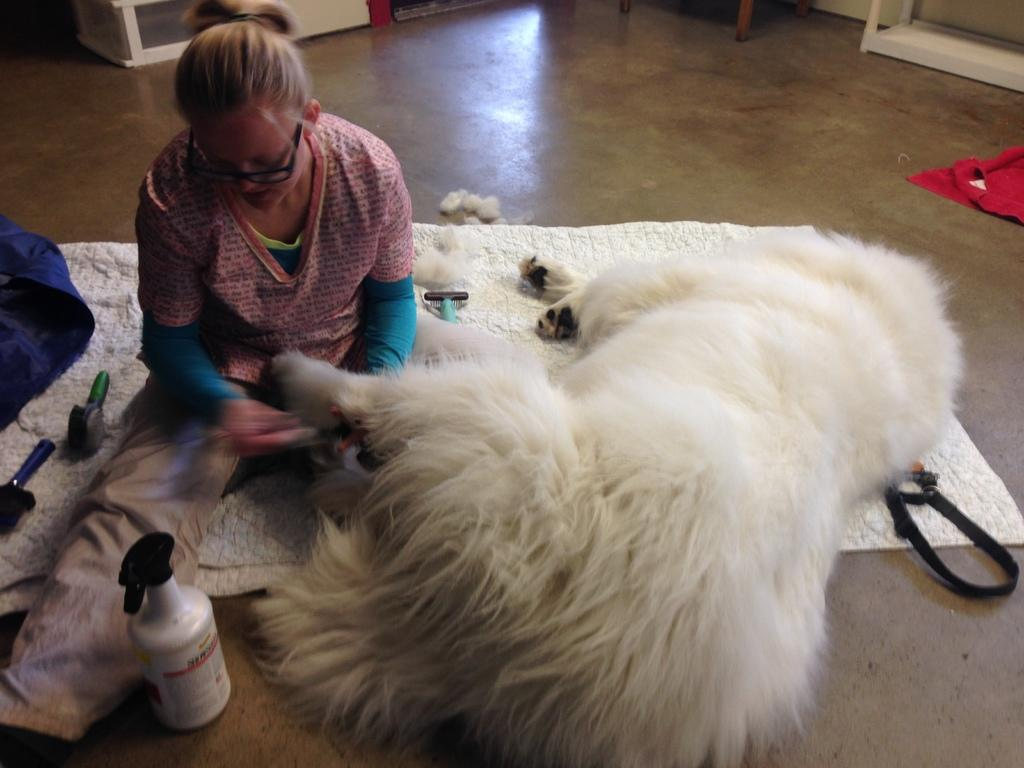What type of flooring is visible in the image? There is a floor in the image. What is on top of the floor? There is a white color carpet on the floor. What living creature can be seen in the image? There is an animal in the image. Are there any human beings present in the image? Yes, there is a person in the image. What can be seen in the background of the image? There are tables in the background of the image. What type of books can be seen in the library in the image? There is no library present in the image, and therefore no books can be seen. How many cats are visible in the image? There is no mention of cats in the provided facts, so we cannot determine the number of cats in the image. 